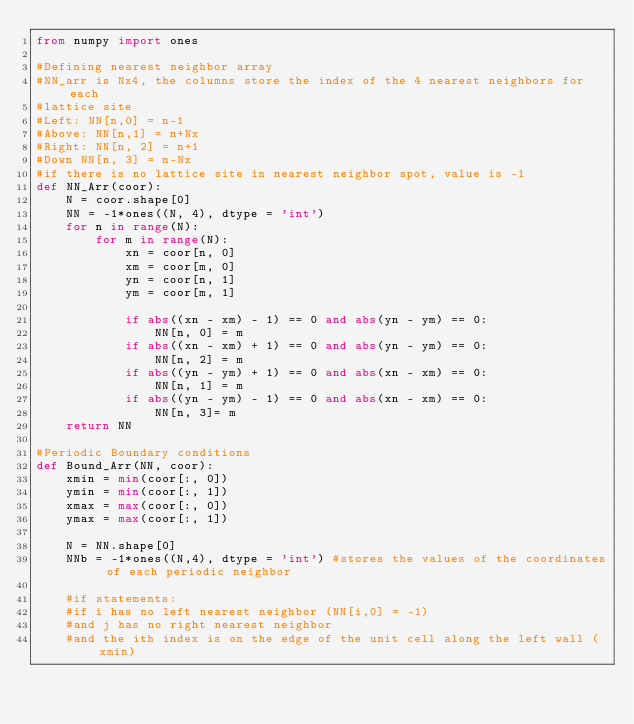<code> <loc_0><loc_0><loc_500><loc_500><_Python_>from numpy import ones

#Defining nearest neighbor array
#NN_arr is Nx4, the columns store the index of the 4 nearest neighbors for each
#lattice site
#Left: NN[n,0] = n-1
#Above: NN[n,1] = n+Nx
#Right: NN[n, 2] = n+1
#Down NN[n, 3] = n-Nx
#if there is no lattice site in nearest neighbor spot, value is -1
def NN_Arr(coor):
    N = coor.shape[0]
    NN = -1*ones((N, 4), dtype = 'int')
    for n in range(N):
        for m in range(N):
            xn = coor[n, 0]
            xm = coor[m, 0]
            yn = coor[n, 1]
            ym = coor[m, 1]

            if abs((xn - xm) - 1) == 0 and abs(yn - ym) == 0:
                NN[n, 0] = m
            if abs((xn - xm) + 1) == 0 and abs(yn - ym) == 0:
                NN[n, 2] = m
            if abs((yn - ym) + 1) == 0 and abs(xn - xm) == 0:
                NN[n, 1] = m
            if abs((yn - ym) - 1) == 0 and abs(xn - xm) == 0:
                NN[n, 3]= m
    return NN

#Periodic Boundary conditions
def Bound_Arr(NN, coor):
    xmin = min(coor[:, 0])
    ymin = min(coor[:, 1])
    xmax = max(coor[:, 0])
    ymax = max(coor[:, 1])

    N = NN.shape[0]
    NNb = -1*ones((N,4), dtype = 'int') #stores the values of the coordinates of each periodic neighbor

    #if statements:
    #if i has no left nearest neighbor (NN[i,0] = -1)
    #and j has no right nearest neighbor
    #and the ith index is on the edge of the unit cell along the left wall (xmin)</code> 